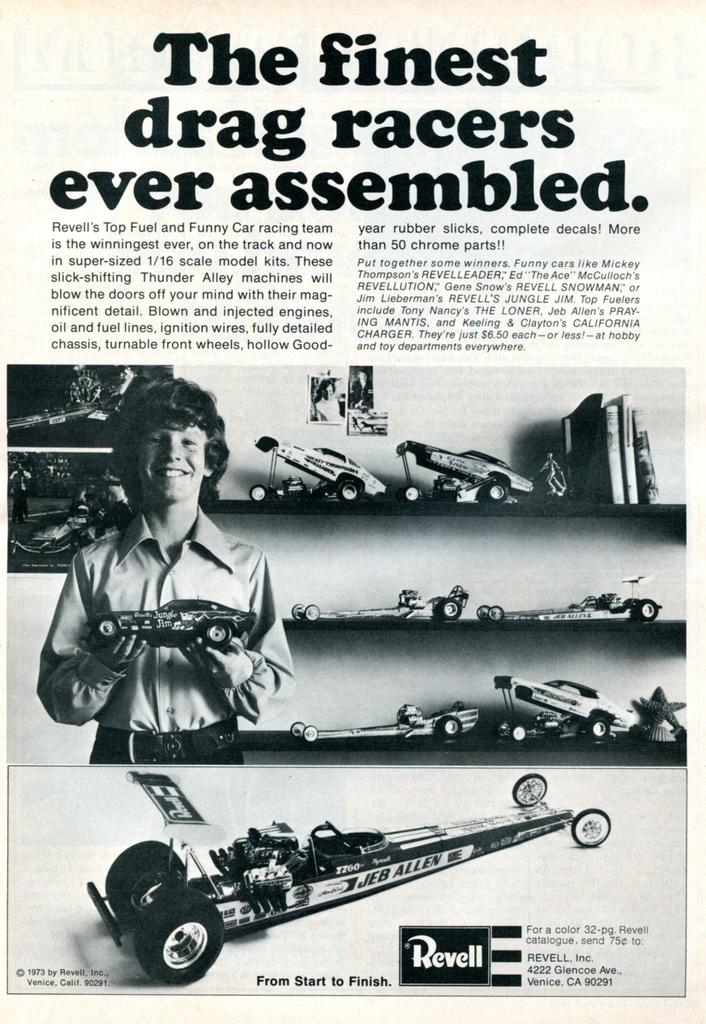Who is in the image? There is a boy in the image. What is the boy holding? The boy is holding a toy car. What is the boy's expression? The boy is smiling. What other items can be seen in the image? There are toys, photos, and books in the image. Is there any text visible in the image? Yes, there is text in the image. How much zephyr is present in the image? There is no mention of zephyr in the image, as it refers to a gentle breeze and is not a visible object. 